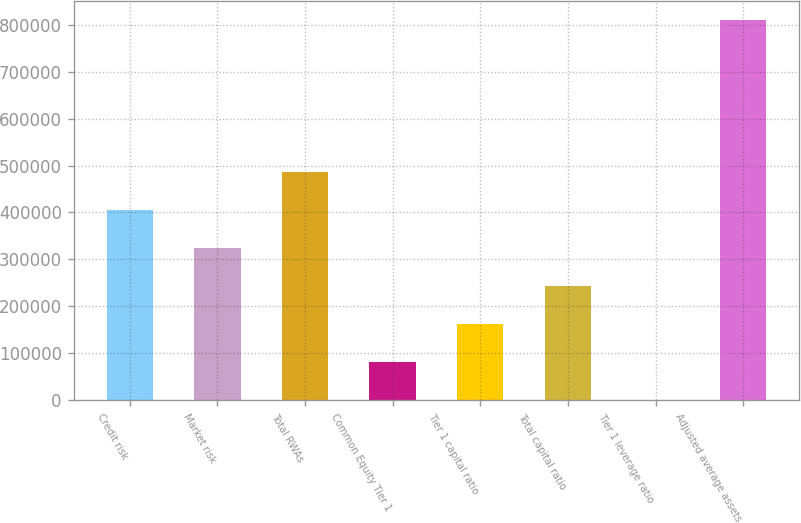<chart> <loc_0><loc_0><loc_500><loc_500><bar_chart><fcel>Credit risk<fcel>Market risk<fcel>Total RWAs<fcel>Common Equity Tier 1<fcel>Tier 1 capital ratio<fcel>Total capital ratio<fcel>Tier 1 leverage ratio<fcel>Adjusted average assets<nl><fcel>405266<fcel>324214<fcel>486318<fcel>81059.5<fcel>162111<fcel>243163<fcel>7.9<fcel>810524<nl></chart> 